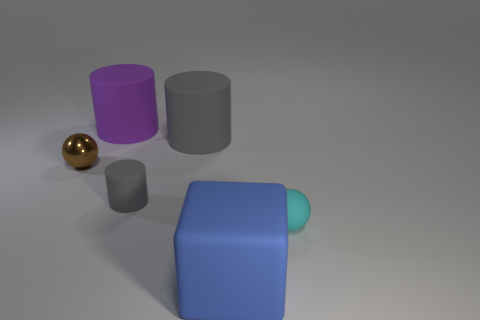Subtract all large cylinders. How many cylinders are left? 1 Subtract all gray cylinders. How many cylinders are left? 1 Subtract 1 cubes. How many cubes are left? 0 Add 4 large rubber cylinders. How many large rubber cylinders are left? 6 Add 2 large gray rubber spheres. How many large gray rubber spheres exist? 2 Add 4 big yellow cubes. How many objects exist? 10 Subtract 0 purple cubes. How many objects are left? 6 Subtract all balls. How many objects are left? 4 Subtract all green cubes. Subtract all cyan cylinders. How many cubes are left? 1 Subtract all yellow blocks. How many gray spheres are left? 0 